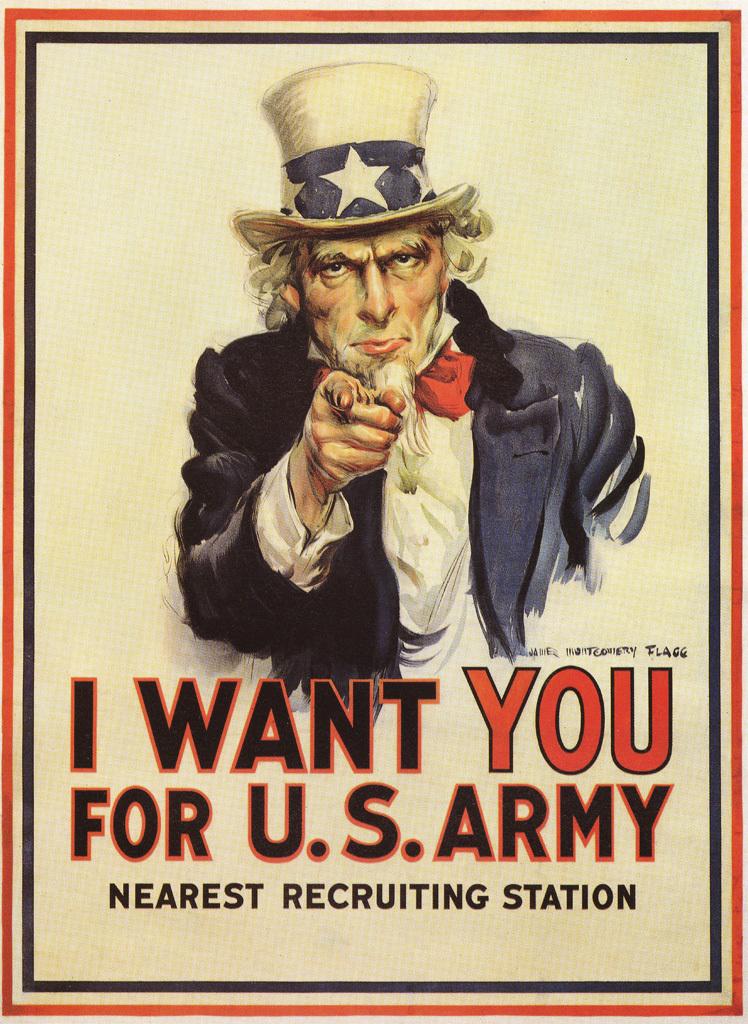What army is this?
Give a very brief answer. U.s. Where do you sign up for the army according to the poster?
Your answer should be very brief. Nearest recruiting station. 